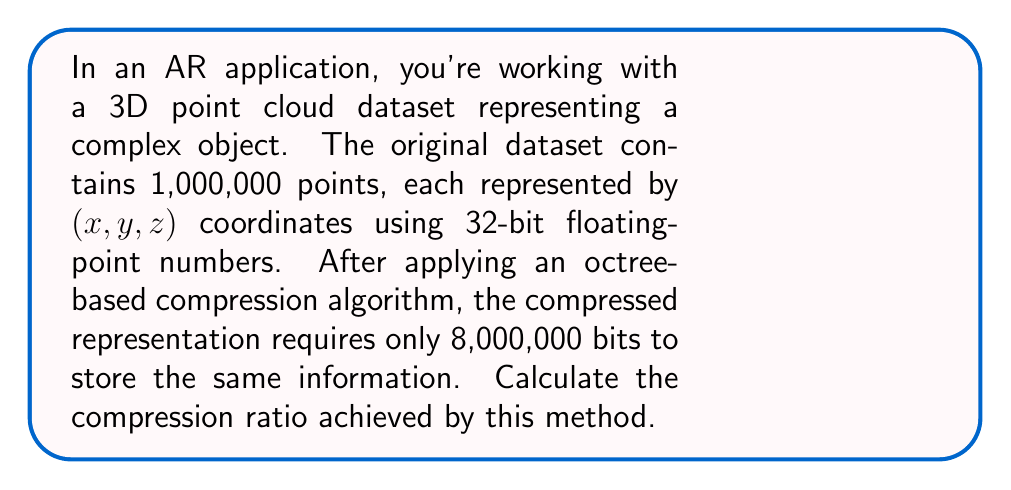Help me with this question. Let's approach this step-by-step:

1) First, calculate the size of the original dataset:
   - Each point has 3 coordinates (x, y, z)
   - Each coordinate is a 32-bit float
   - Total points = 1,000,000

   Original size = $1,000,000 \times 3 \times 32$ bits
                 = $96,000,000$ bits

2) The compressed size is given as 8,000,000 bits

3) The compression ratio is calculated as:

   $$ \text{Compression Ratio} = \frac{\text{Original Size}}{\text{Compressed Size}} $$

4) Substituting the values:

   $$ \text{Compression Ratio} = \frac{96,000,000}{8,000,000} = 12 $$

5) This means the compressed representation is 12 times smaller than the original dataset.

6) To express this as a percentage of the original size:

   $$ \text{Percentage} = \frac{8,000,000}{96,000,000} \times 100\% = 8.33\% $$

   So the compressed data takes up only 8.33% of the original space.
Answer: 12:1 (or 12) 